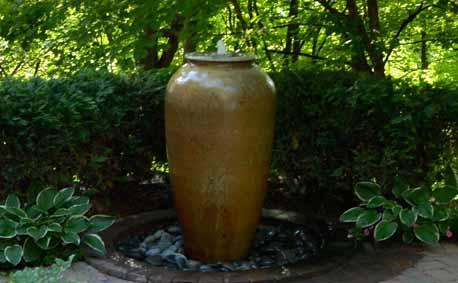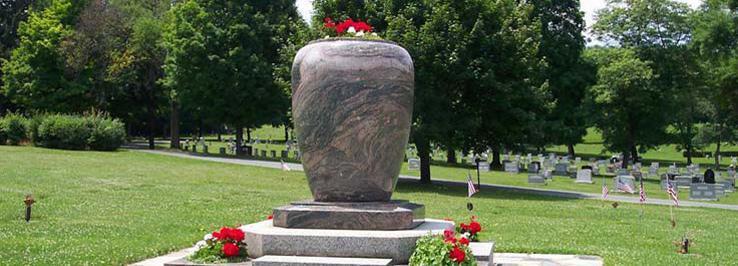The first image is the image on the left, the second image is the image on the right. Assess this claim about the two images: "There is a vase that holds a water  fountain .". Correct or not? Answer yes or no. Yes. The first image is the image on the left, the second image is the image on the right. Given the left and right images, does the statement "One image includes a shiny greenish vessel used as an outdoor fountain, and the other image shows a flower-filled stone-look planter with a pedestal base." hold true? Answer yes or no. Yes. 